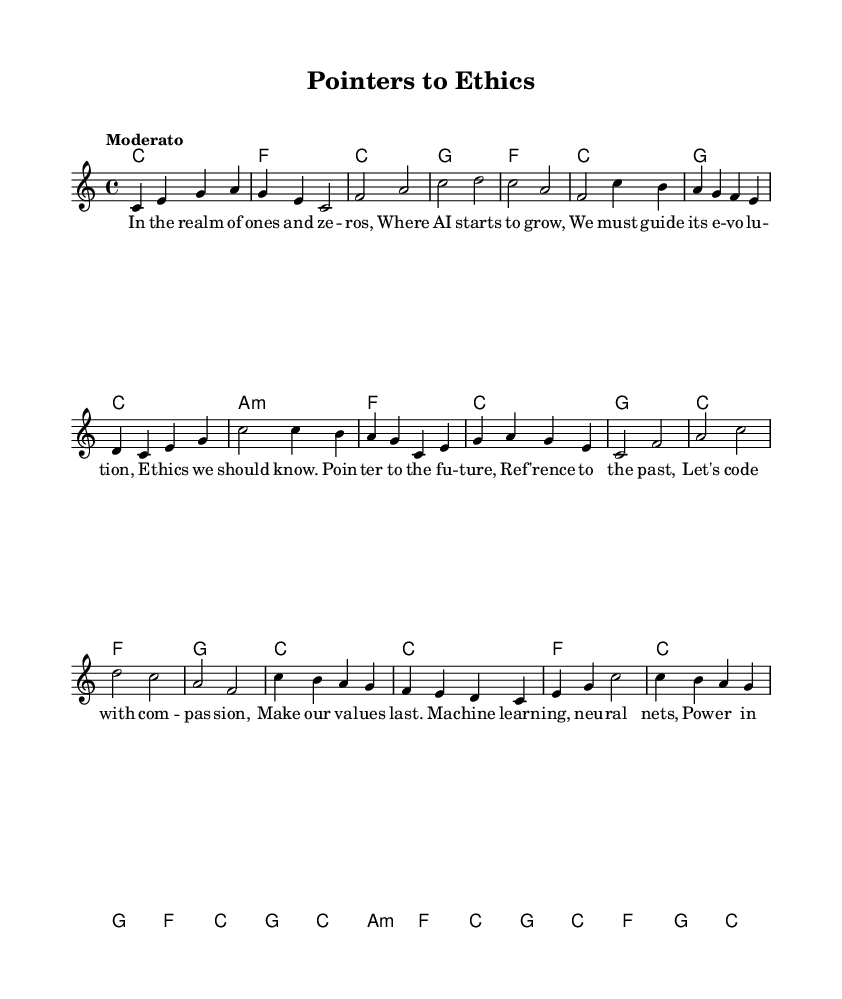What is the key signature of this music? The key signature is indicated at the beginning of the score, which shows there are no sharps or flats. The score is in C major.
Answer: C major What is the time signature of this piece? The time signature is found at the beginning of the score, directly following the key signature, and it shows 4 beats per measure.
Answer: 4/4 What is the tempo marking for this piece? The tempo marking is indicated in the global block of the code. It states "Moderato," which means moderate speed.
Answer: Moderato How many verses are there in total? By looking at the lyrical content structured in the score, we can see the first verse, the second verse, and repeated choruses, totaling two verses.
Answer: 2 Which line contains the lyrics discussing machine learning? The lyrics referencing machine learning are found in the second verse, clearly articulating concepts related to machine learning and control of data.
Answer: verse two What musical form does this song follow? The song follows a common Folk structure: verse-chorus-verse-chorus. This structure consists of alternating verses and choruses.
Answer: Verse-Chorus What type of song is represented in this sheet music? The song is a protest song that deals with ethical concerns in technology and artificial intelligence, as indicated by the lyrics addressing these issues.
Answer: Protest song 